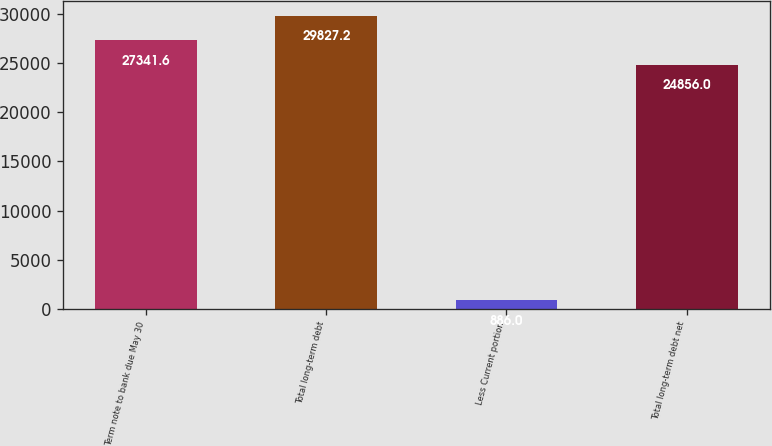<chart> <loc_0><loc_0><loc_500><loc_500><bar_chart><fcel>Term note to bank due May 30<fcel>Total long-term debt<fcel>Less Current portion<fcel>Total long-term debt net<nl><fcel>27341.6<fcel>29827.2<fcel>886<fcel>24856<nl></chart> 